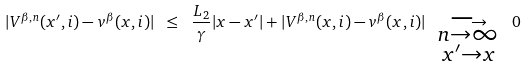Convert formula to latex. <formula><loc_0><loc_0><loc_500><loc_500>| V ^ { \beta , n } ( x ^ { \prime } , i ) - v ^ { \beta } ( x , i ) | \ \leq \ \frac { L _ { 2 } } { \gamma } | x - x ^ { \prime } | + | V ^ { \beta , n } ( x , i ) - v ^ { \beta } ( x , i ) | \ \underset { \substack { n \rightarrow \infty \\ x ^ { \prime } \rightarrow x } } { \longrightarrow } \ 0</formula> 